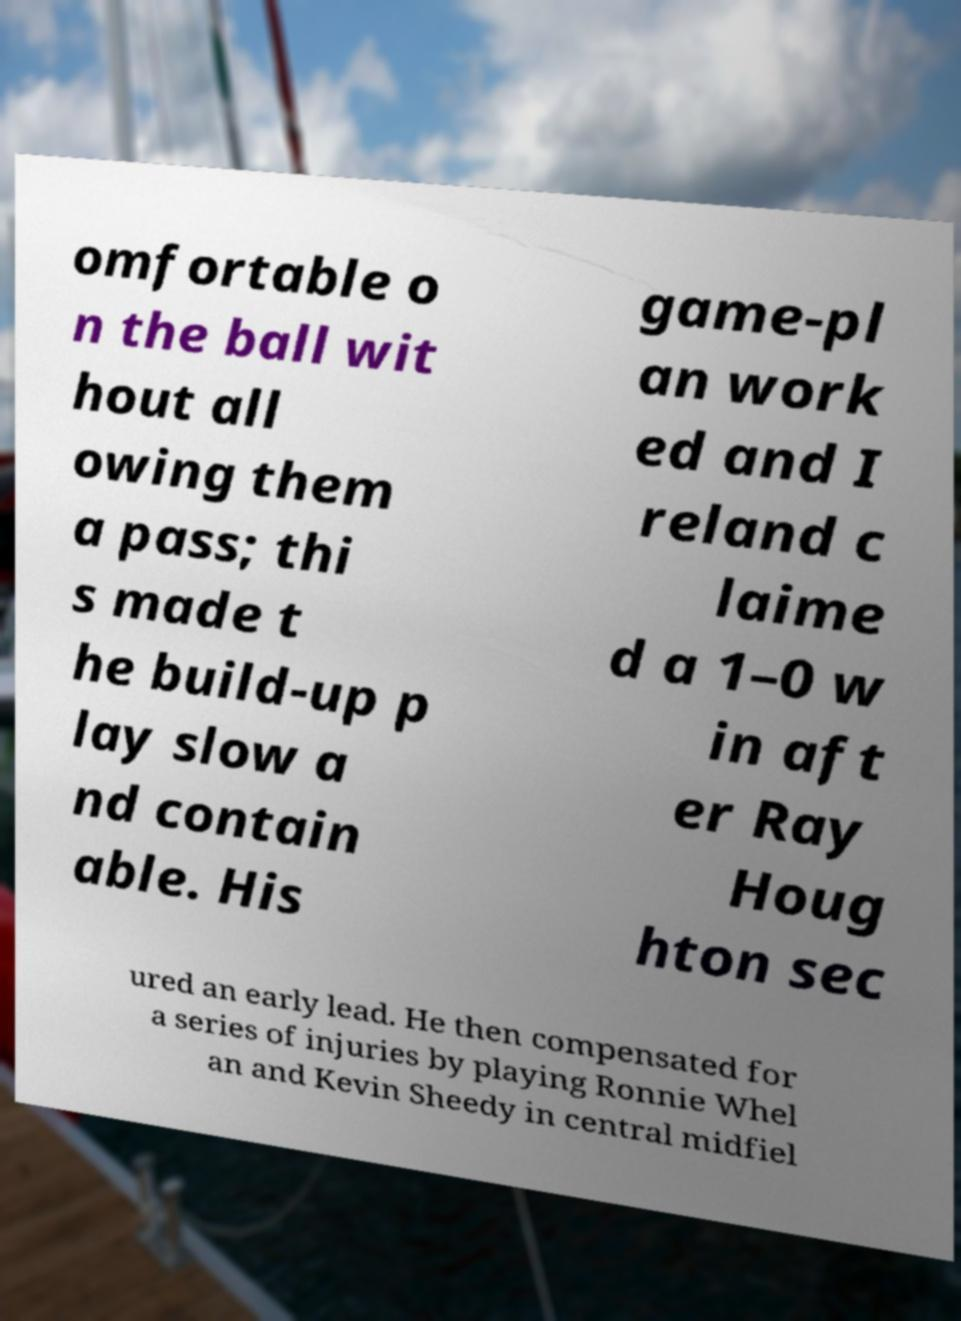There's text embedded in this image that I need extracted. Can you transcribe it verbatim? omfortable o n the ball wit hout all owing them a pass; thi s made t he build-up p lay slow a nd contain able. His game-pl an work ed and I reland c laime d a 1–0 w in aft er Ray Houg hton sec ured an early lead. He then compensated for a series of injuries by playing Ronnie Whel an and Kevin Sheedy in central midfiel 